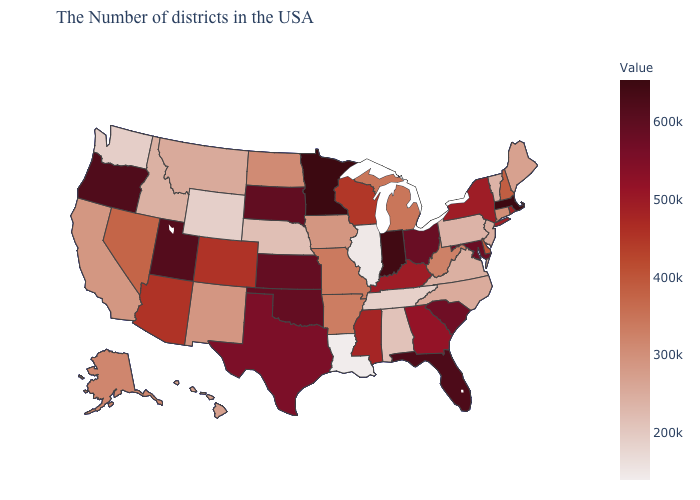Among the states that border Connecticut , does New York have the lowest value?
Concise answer only. No. Which states have the highest value in the USA?
Short answer required. Minnesota. Among the states that border Kansas , does Oklahoma have the lowest value?
Answer briefly. No. 